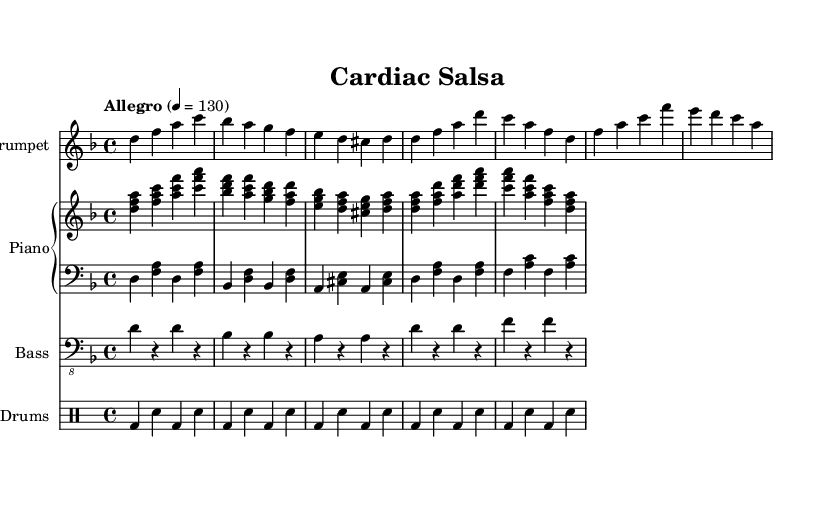What is the key signature of this music? The key signature is indicated by the sharp or flat symbols at the beginning of the staff. In this case, it is D minor, which has one flat (B flat).
Answer: D minor What is the time signature of this music? The time signature is represented by the numbers at the beginning of the staff, right after the key signature. Here, it is 4/4, meaning there are four beats in each measure and the quarter note gets one beat.
Answer: 4/4 What is the tempo marking for this piece? The tempo marking is found at the beginning of the score, stating the speed of the music. It indicates an Allegro tempo, which generally means a lively and fast pace, specified here as 130 beats per minute.
Answer: Allegro 4 = 130 How many bars are in the introduction section? By examining the introduction section, we count the measures. The introduction consists of three bars: one for each phrase separated by vertical lines.
Answer: 3 What is the rhythmic motif used in drums during the introductory section? The rhythmic pattern in the drums can be found in the drum staff part. It demonstrates a consistent pattern of bass drum hits paired with snare hits, creating a rhythmic pulse typical of Latin music.
Answer: Bass and snare What instrument plays the melody in the introduction? The melody can be identified by looking at the staff notation; the trumpet part contains the highest notes, which typically carry the melodic line, especially during the introduction.
Answer: Trumpet How does the harmony change in the verse compared to the introduction? Analyzing the chord progressions in the piano parts reveals that the introduction features more complex harmonies while the verse simplifies to fewer chords, evoking a sense of resolution in rhythm.
Answer: Simplified harmonies 